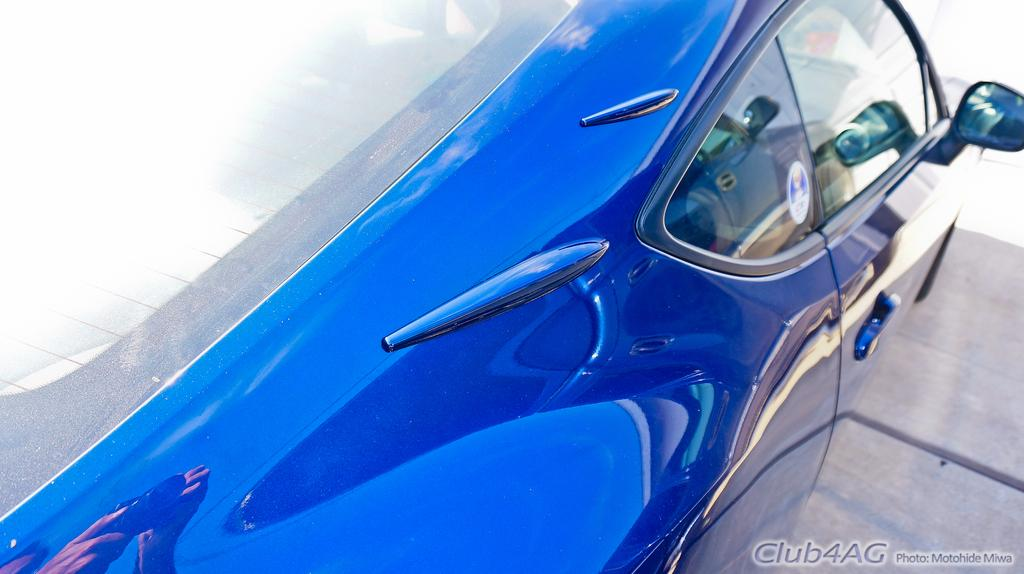What is the main subject of the image? The main subject of the image is a vehicle. Can you describe the position of the vehicle in the image? The vehicle is on the ground in the image. Is there any text visible on the vehicle in the image? Yes, there is text visible on the vehicle in the bottom right. What type of farm animals can be seen grazing in the alley next to the vehicle in the image? There are no farm animals or alley present in the image; it only features a vehicle on the ground. 